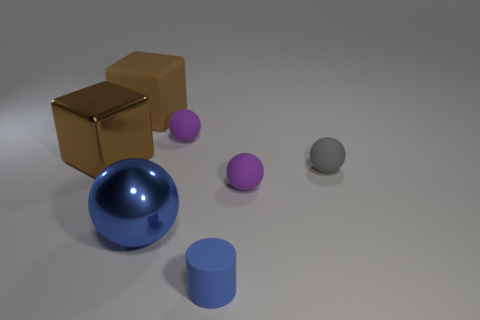Add 1 small matte things. How many objects exist? 8 Subtract all cubes. How many objects are left? 5 Add 7 blue cylinders. How many blue cylinders are left? 8 Add 6 blue rubber cylinders. How many blue rubber cylinders exist? 7 Subtract 0 cyan balls. How many objects are left? 7 Subtract all tiny blue shiny things. Subtract all blue rubber objects. How many objects are left? 6 